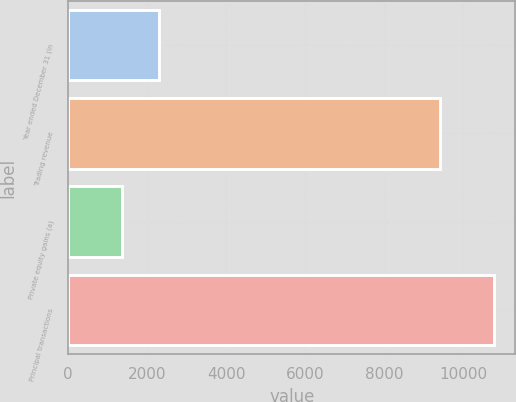Convert chart to OTSL. <chart><loc_0><loc_0><loc_500><loc_500><bar_chart><fcel>Year ended December 31 (in<fcel>Trading revenue<fcel>Private equity gains (a)<fcel>Principal transactions<nl><fcel>2301.8<fcel>9418<fcel>1360<fcel>10778<nl></chart> 